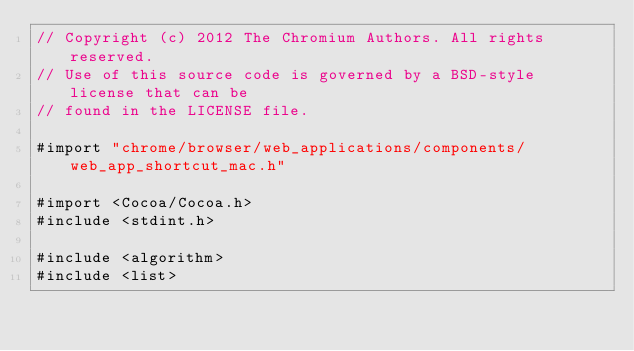Convert code to text. <code><loc_0><loc_0><loc_500><loc_500><_ObjectiveC_>// Copyright (c) 2012 The Chromium Authors. All rights reserved.
// Use of this source code is governed by a BSD-style license that can be
// found in the LICENSE file.

#import "chrome/browser/web_applications/components/web_app_shortcut_mac.h"

#import <Cocoa/Cocoa.h>
#include <stdint.h>

#include <algorithm>
#include <list></code> 